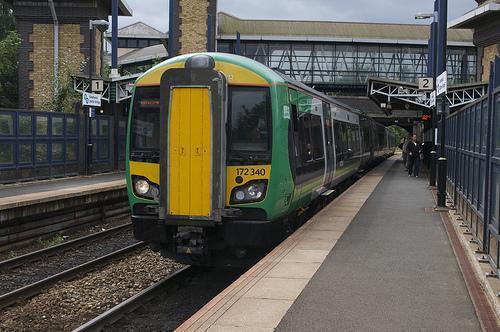How many trains are in the picture?
Give a very brief answer. 1. 